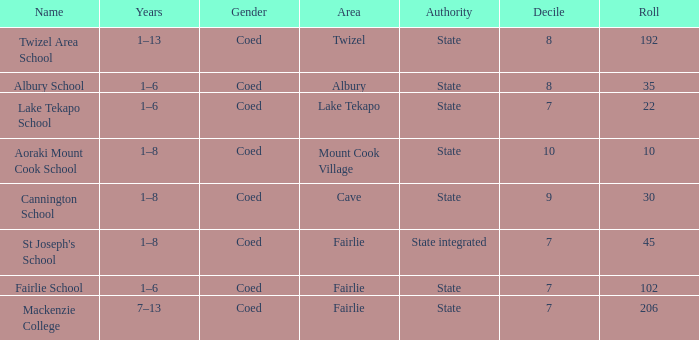What is the total Decile that has a state authority, fairlie area and roll smarter than 206? 1.0. 